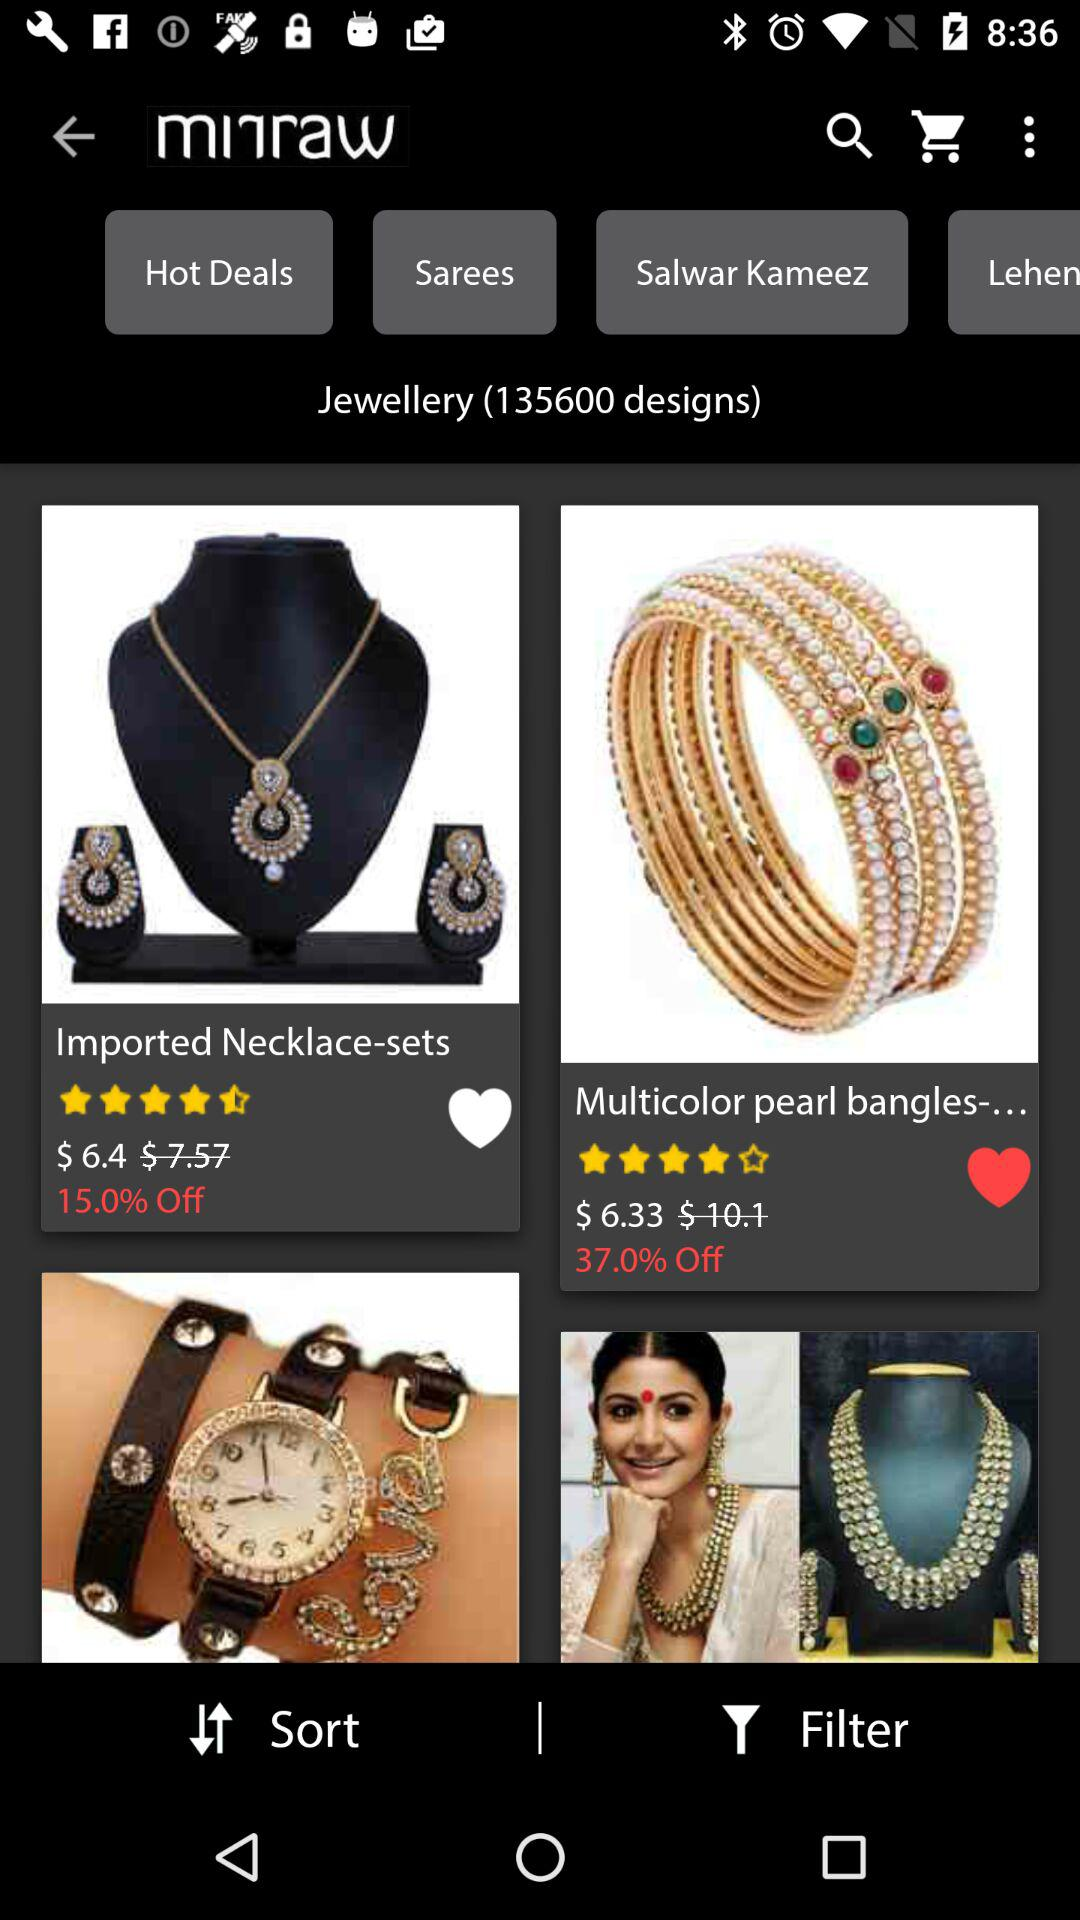What is the rating of the bangles? The rating is 4 stars. 